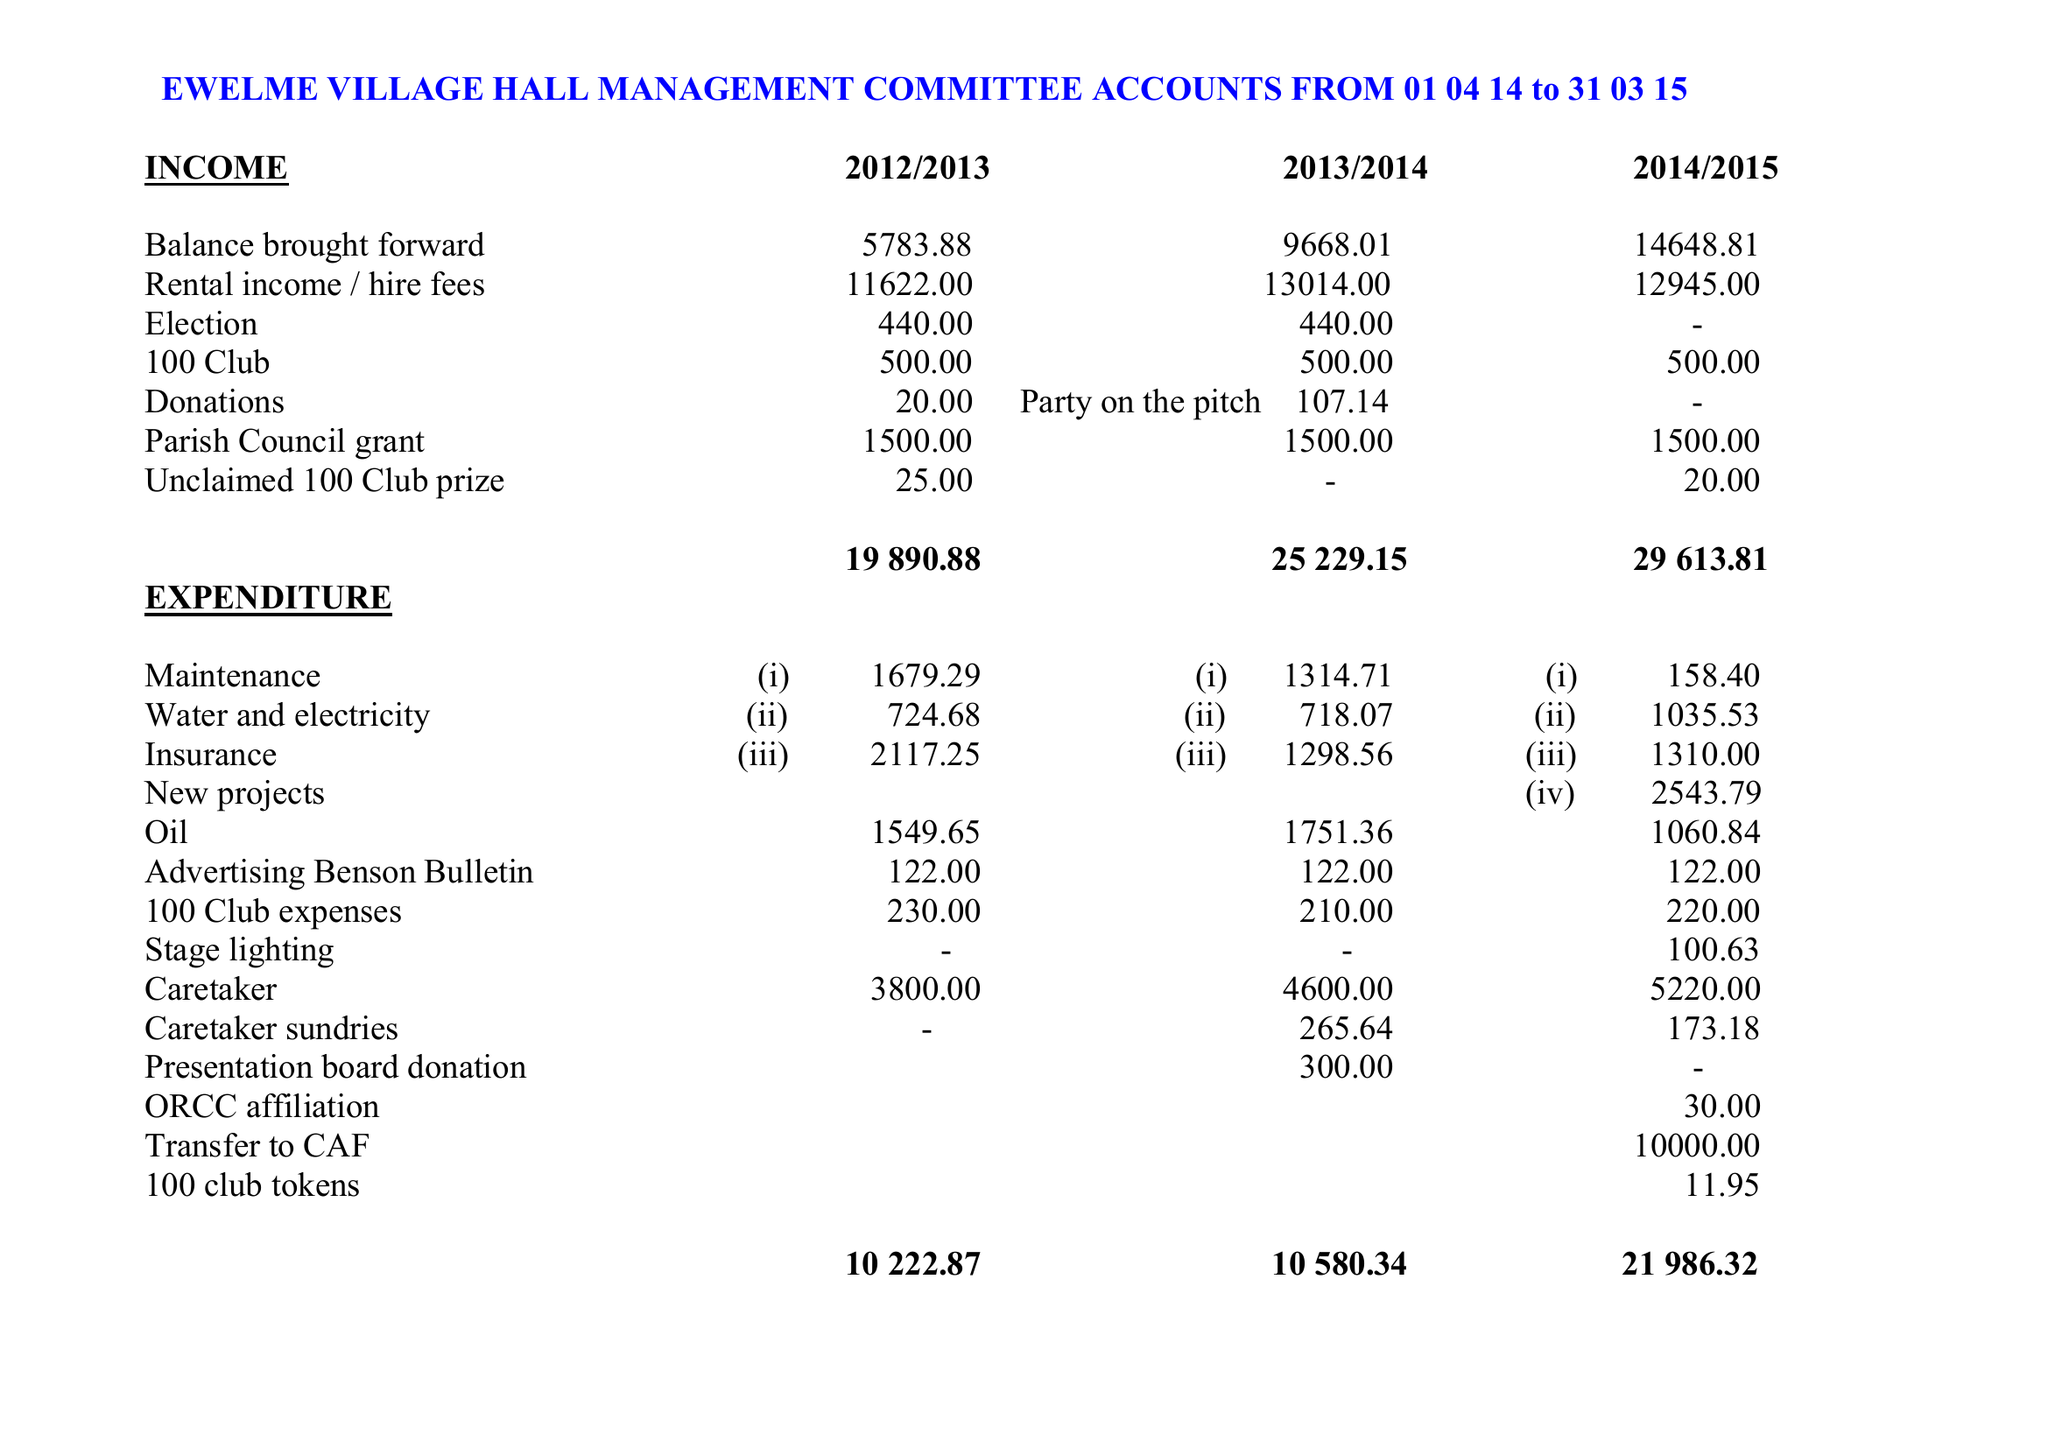What is the value for the spending_annually_in_british_pounds?
Answer the question using a single word or phrase. 21986.00 